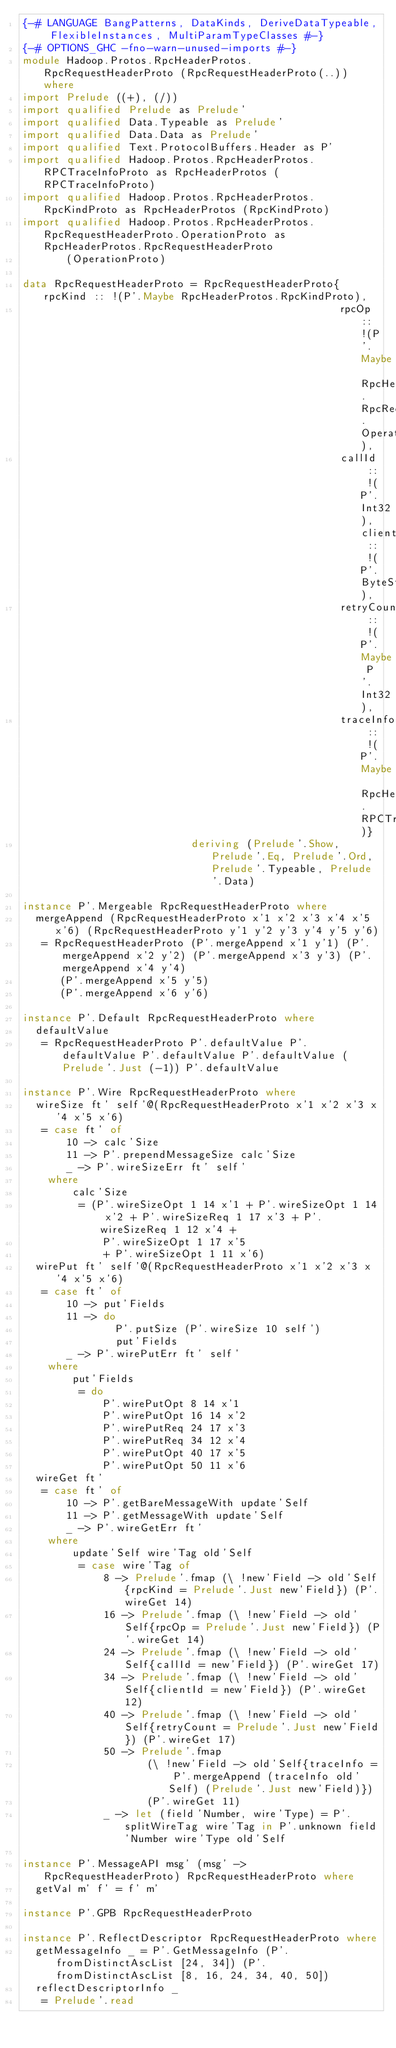Convert code to text. <code><loc_0><loc_0><loc_500><loc_500><_Haskell_>{-# LANGUAGE BangPatterns, DataKinds, DeriveDataTypeable, FlexibleInstances, MultiParamTypeClasses #-}
{-# OPTIONS_GHC -fno-warn-unused-imports #-}
module Hadoop.Protos.RpcHeaderProtos.RpcRequestHeaderProto (RpcRequestHeaderProto(..)) where
import Prelude ((+), (/))
import qualified Prelude as Prelude'
import qualified Data.Typeable as Prelude'
import qualified Data.Data as Prelude'
import qualified Text.ProtocolBuffers.Header as P'
import qualified Hadoop.Protos.RpcHeaderProtos.RPCTraceInfoProto as RpcHeaderProtos (RPCTraceInfoProto)
import qualified Hadoop.Protos.RpcHeaderProtos.RpcKindProto as RpcHeaderProtos (RpcKindProto)
import qualified Hadoop.Protos.RpcHeaderProtos.RpcRequestHeaderProto.OperationProto as RpcHeaderProtos.RpcRequestHeaderProto
       (OperationProto)
 
data RpcRequestHeaderProto = RpcRequestHeaderProto{rpcKind :: !(P'.Maybe RpcHeaderProtos.RpcKindProto),
                                                   rpcOp :: !(P'.Maybe RpcHeaderProtos.RpcRequestHeaderProto.OperationProto),
                                                   callId :: !(P'.Int32), clientId :: !(P'.ByteString),
                                                   retryCount :: !(P'.Maybe P'.Int32),
                                                   traceInfo :: !(P'.Maybe RpcHeaderProtos.RPCTraceInfoProto)}
                           deriving (Prelude'.Show, Prelude'.Eq, Prelude'.Ord, Prelude'.Typeable, Prelude'.Data)
 
instance P'.Mergeable RpcRequestHeaderProto where
  mergeAppend (RpcRequestHeaderProto x'1 x'2 x'3 x'4 x'5 x'6) (RpcRequestHeaderProto y'1 y'2 y'3 y'4 y'5 y'6)
   = RpcRequestHeaderProto (P'.mergeAppend x'1 y'1) (P'.mergeAppend x'2 y'2) (P'.mergeAppend x'3 y'3) (P'.mergeAppend x'4 y'4)
      (P'.mergeAppend x'5 y'5)
      (P'.mergeAppend x'6 y'6)
 
instance P'.Default RpcRequestHeaderProto where
  defaultValue
   = RpcRequestHeaderProto P'.defaultValue P'.defaultValue P'.defaultValue P'.defaultValue (Prelude'.Just (-1)) P'.defaultValue
 
instance P'.Wire RpcRequestHeaderProto where
  wireSize ft' self'@(RpcRequestHeaderProto x'1 x'2 x'3 x'4 x'5 x'6)
   = case ft' of
       10 -> calc'Size
       11 -> P'.prependMessageSize calc'Size
       _ -> P'.wireSizeErr ft' self'
    where
        calc'Size
         = (P'.wireSizeOpt 1 14 x'1 + P'.wireSizeOpt 1 14 x'2 + P'.wireSizeReq 1 17 x'3 + P'.wireSizeReq 1 12 x'4 +
             P'.wireSizeOpt 1 17 x'5
             + P'.wireSizeOpt 1 11 x'6)
  wirePut ft' self'@(RpcRequestHeaderProto x'1 x'2 x'3 x'4 x'5 x'6)
   = case ft' of
       10 -> put'Fields
       11 -> do
               P'.putSize (P'.wireSize 10 self')
               put'Fields
       _ -> P'.wirePutErr ft' self'
    where
        put'Fields
         = do
             P'.wirePutOpt 8 14 x'1
             P'.wirePutOpt 16 14 x'2
             P'.wirePutReq 24 17 x'3
             P'.wirePutReq 34 12 x'4
             P'.wirePutOpt 40 17 x'5
             P'.wirePutOpt 50 11 x'6
  wireGet ft'
   = case ft' of
       10 -> P'.getBareMessageWith update'Self
       11 -> P'.getMessageWith update'Self
       _ -> P'.wireGetErr ft'
    where
        update'Self wire'Tag old'Self
         = case wire'Tag of
             8 -> Prelude'.fmap (\ !new'Field -> old'Self{rpcKind = Prelude'.Just new'Field}) (P'.wireGet 14)
             16 -> Prelude'.fmap (\ !new'Field -> old'Self{rpcOp = Prelude'.Just new'Field}) (P'.wireGet 14)
             24 -> Prelude'.fmap (\ !new'Field -> old'Self{callId = new'Field}) (P'.wireGet 17)
             34 -> Prelude'.fmap (\ !new'Field -> old'Self{clientId = new'Field}) (P'.wireGet 12)
             40 -> Prelude'.fmap (\ !new'Field -> old'Self{retryCount = Prelude'.Just new'Field}) (P'.wireGet 17)
             50 -> Prelude'.fmap
                    (\ !new'Field -> old'Self{traceInfo = P'.mergeAppend (traceInfo old'Self) (Prelude'.Just new'Field)})
                    (P'.wireGet 11)
             _ -> let (field'Number, wire'Type) = P'.splitWireTag wire'Tag in P'.unknown field'Number wire'Type old'Self
 
instance P'.MessageAPI msg' (msg' -> RpcRequestHeaderProto) RpcRequestHeaderProto where
  getVal m' f' = f' m'
 
instance P'.GPB RpcRequestHeaderProto
 
instance P'.ReflectDescriptor RpcRequestHeaderProto where
  getMessageInfo _ = P'.GetMessageInfo (P'.fromDistinctAscList [24, 34]) (P'.fromDistinctAscList [8, 16, 24, 34, 40, 50])
  reflectDescriptorInfo _
   = Prelude'.read</code> 